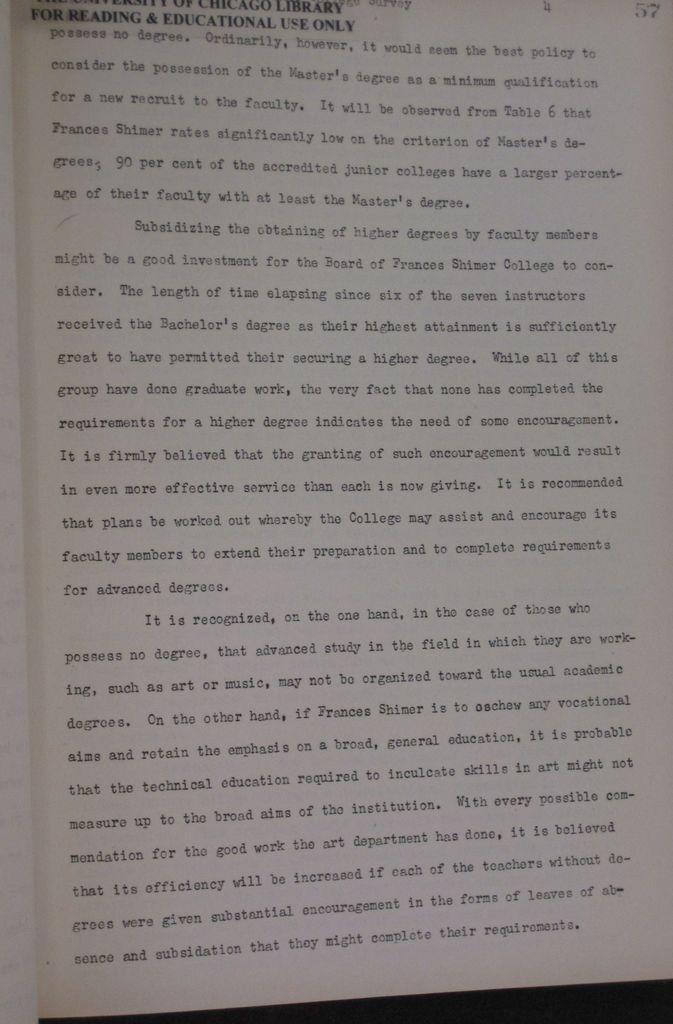<image>
Create a compact narrative representing the image presented. A textbook page with the title For Reading Educational Use Only. 